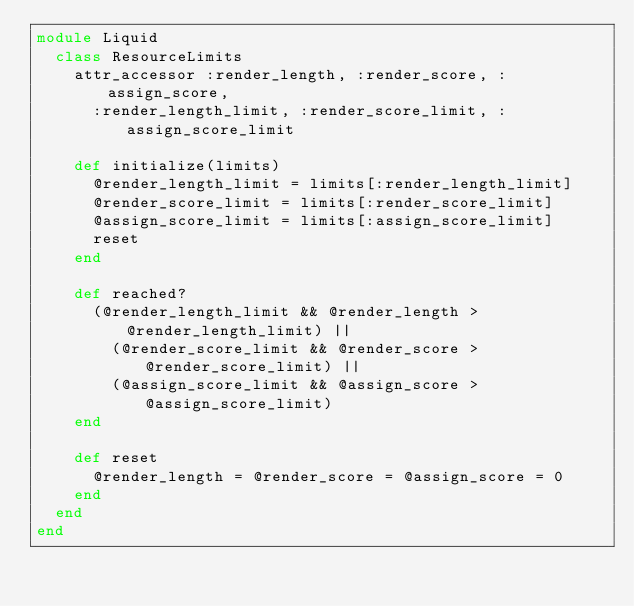Convert code to text. <code><loc_0><loc_0><loc_500><loc_500><_Ruby_>module Liquid
  class ResourceLimits
    attr_accessor :render_length, :render_score, :assign_score,
      :render_length_limit, :render_score_limit, :assign_score_limit

    def initialize(limits)
      @render_length_limit = limits[:render_length_limit]
      @render_score_limit = limits[:render_score_limit]
      @assign_score_limit = limits[:assign_score_limit]
      reset
    end

    def reached?
      (@render_length_limit && @render_length > @render_length_limit) ||
        (@render_score_limit && @render_score > @render_score_limit) ||
        (@assign_score_limit && @assign_score > @assign_score_limit)
    end

    def reset
      @render_length = @render_score = @assign_score = 0
    end
  end
end
</code> 